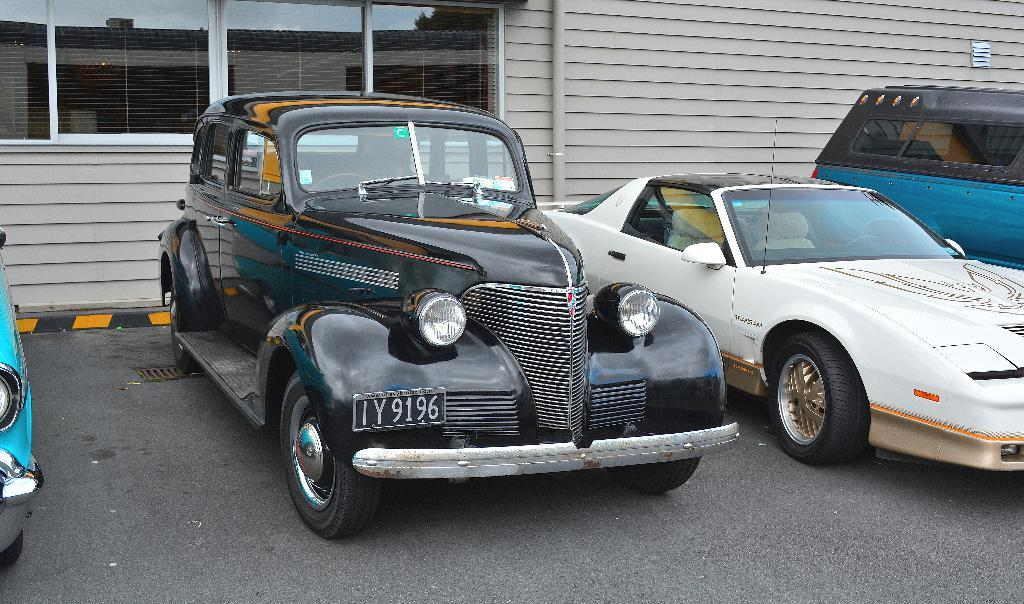What can be seen on the road in the image? There are vehicles on the road in the image. What is visible in the background of the image? There is a building in the background of the image. Can you describe a specific feature of the image? There is a window visible in the image. What is the price of the quarter shown in the image? There is no quarter present in the image, so it is not possible to determine its price. Can you describe the nose of the person in the image? There is no person present in the image, so it is not possible to describe their nose. 